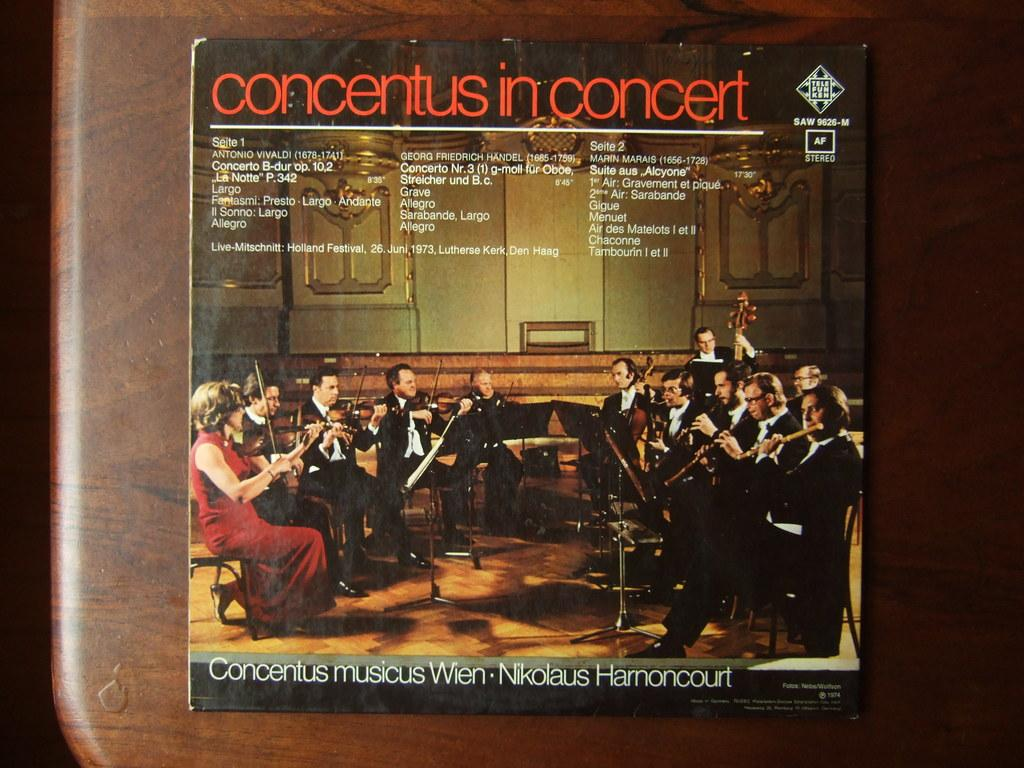<image>
Summarize the visual content of the image. An album cover of concentius in concert showing a symphony. 